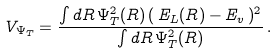<formula> <loc_0><loc_0><loc_500><loc_500>V _ { \Psi _ { T } } = \frac { \int d R \, \Psi _ { T } ^ { 2 } ( R ) \, ( \, E _ { L } ( R ) - E _ { v } \, ) ^ { 2 } } { \int d R \, \Psi _ { T } ^ { 2 } ( R ) } \, .</formula> 